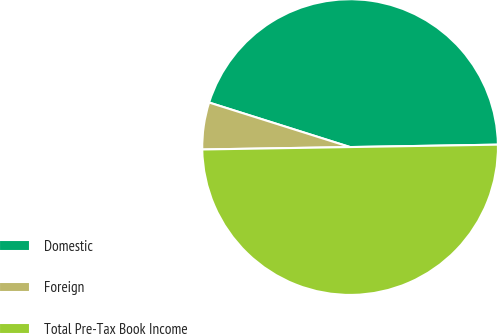Convert chart to OTSL. <chart><loc_0><loc_0><loc_500><loc_500><pie_chart><fcel>Domestic<fcel>Foreign<fcel>Total Pre-Tax Book Income<nl><fcel>44.87%<fcel>5.13%<fcel>50.0%<nl></chart> 